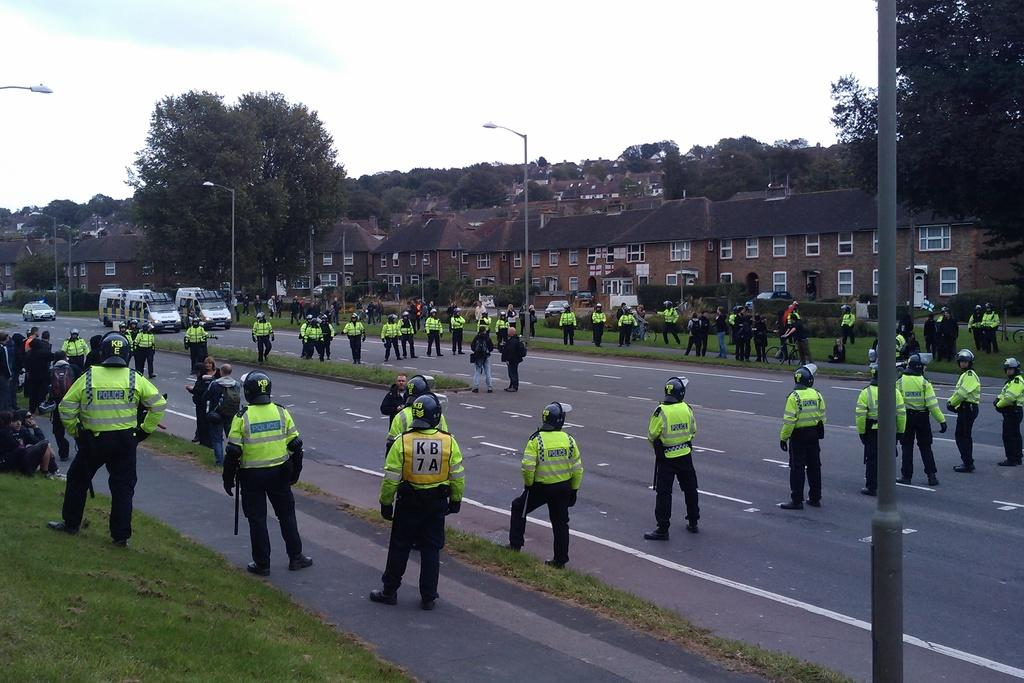What are the police officers doing in the image? The police officers are standing in a circle in the image. Are there any other people present besides the police officers? Yes, there are people beside the police officers in the image. What can be seen in the background of the image? In the background of the image, there are vehicles, houses, and trees. What type of glass is being used by the actor in the image? There is no actor or glass present in the image; it features police officers standing in a circle with people beside them and background elements. 